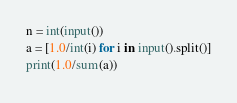<code> <loc_0><loc_0><loc_500><loc_500><_Python_>n = int(input())
a = [1.0/int(i) for i in input().split()]
print(1.0/sum(a))</code> 